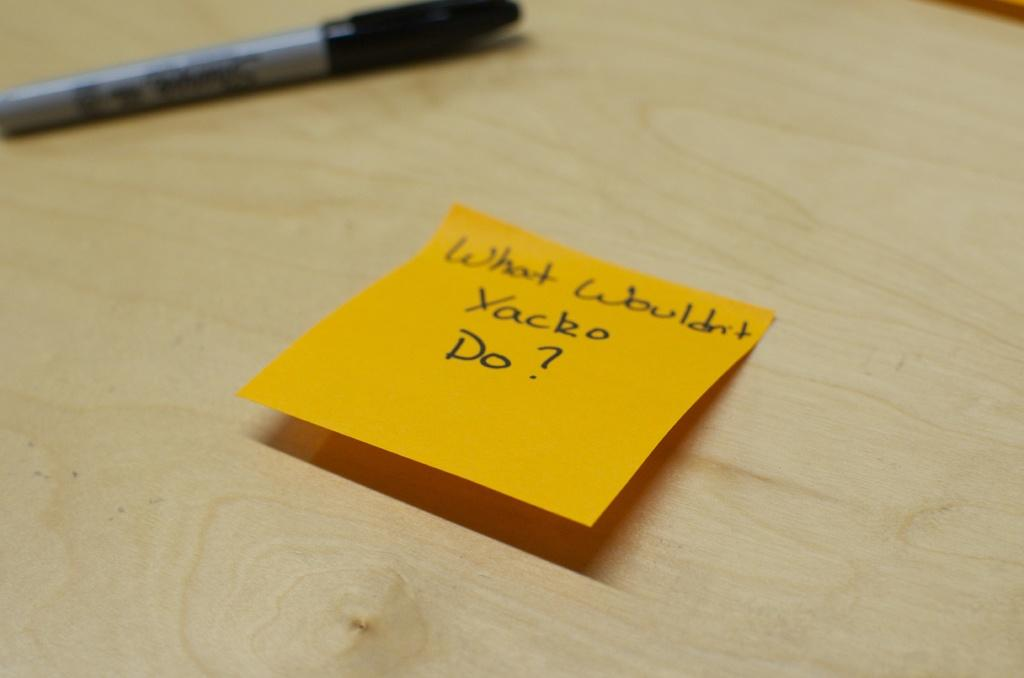What object is present in the image that is commonly used for writing? There is a pen in the image. What is the pen placed on in the image? The pen and paper are on a wooden plank. What is the paper used for in the image? There is text written on the paper. Where is the pen located in relation to the paper? The pen is located at the left top of the image. What type of nerve can be seen affecting the wooden plank in the image? There is no nerve present in the image, and the wooden plank is not affected by any nerve. 